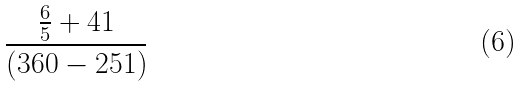Convert formula to latex. <formula><loc_0><loc_0><loc_500><loc_500>\frac { \frac { 6 } { 5 } + 4 1 } { ( 3 6 0 - 2 5 1 ) }</formula> 